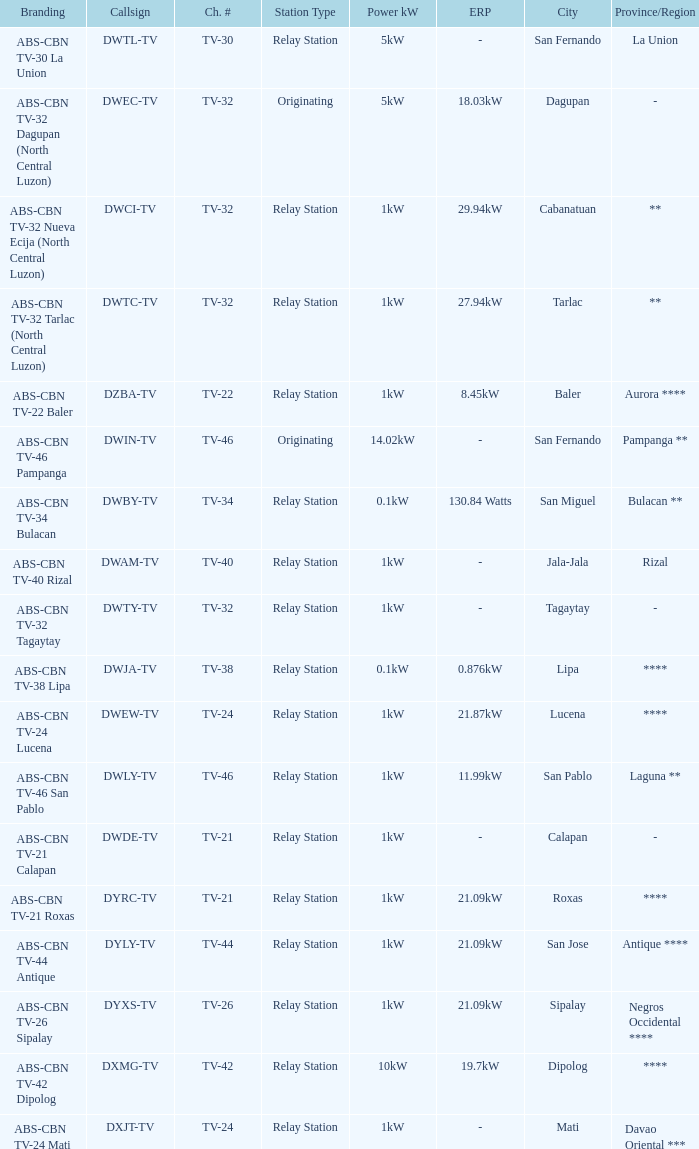How many identifications exist where the power kw (erp) is 1kw (2 1.0. 